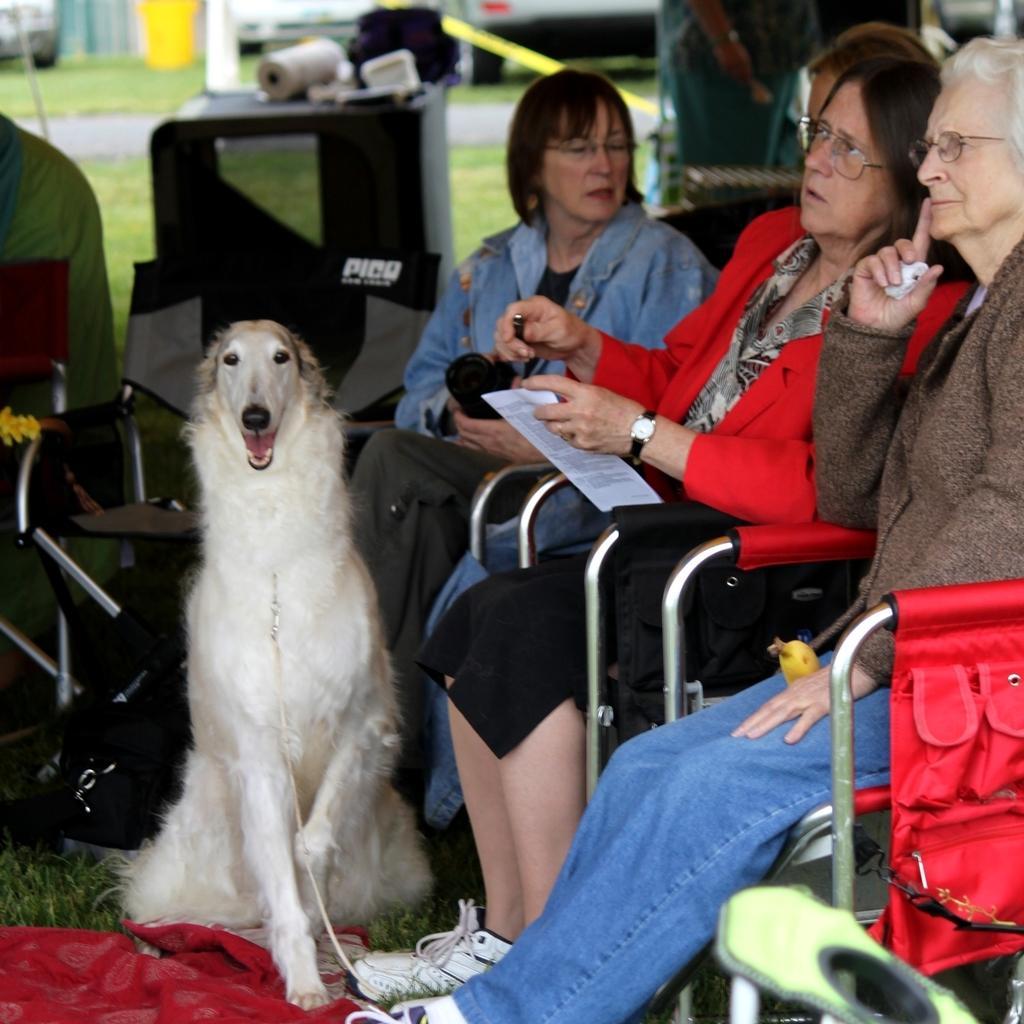Can you describe this image briefly? In this picture we can see three women sitting on chairs holding papers in their hands and in front of them there is dog and in background we can see grass, roller, stick. 